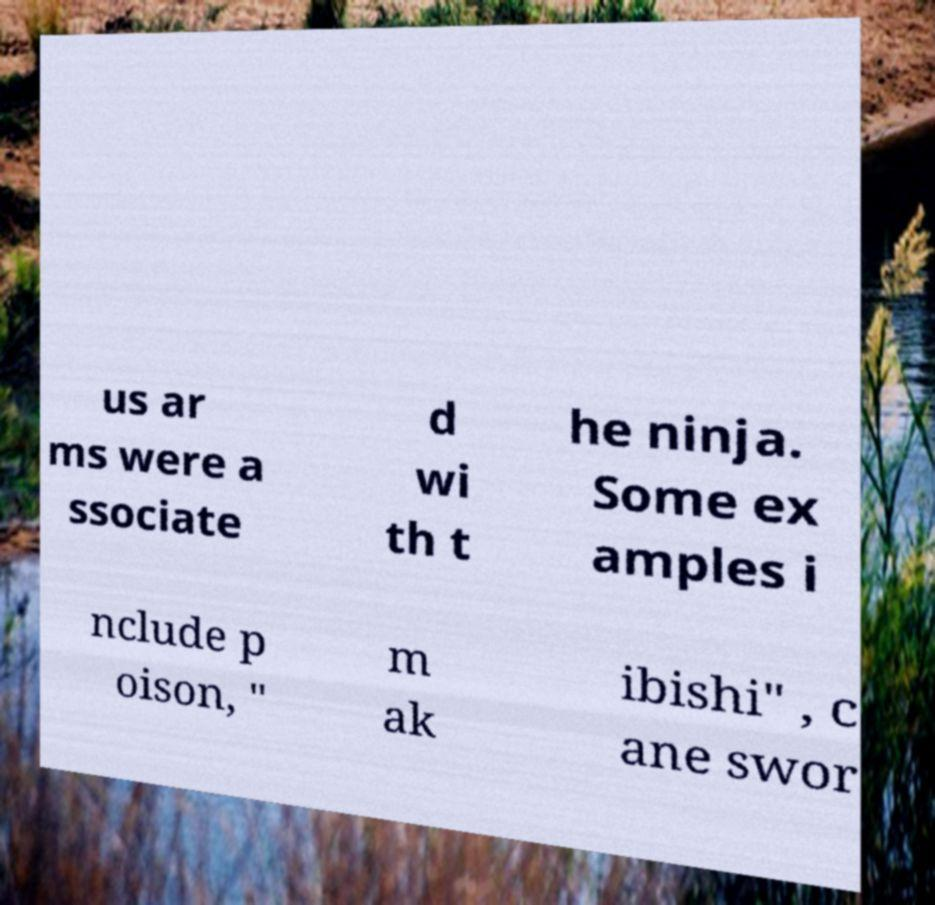For documentation purposes, I need the text within this image transcribed. Could you provide that? us ar ms were a ssociate d wi th t he ninja. Some ex amples i nclude p oison, " m ak ibishi" , c ane swor 